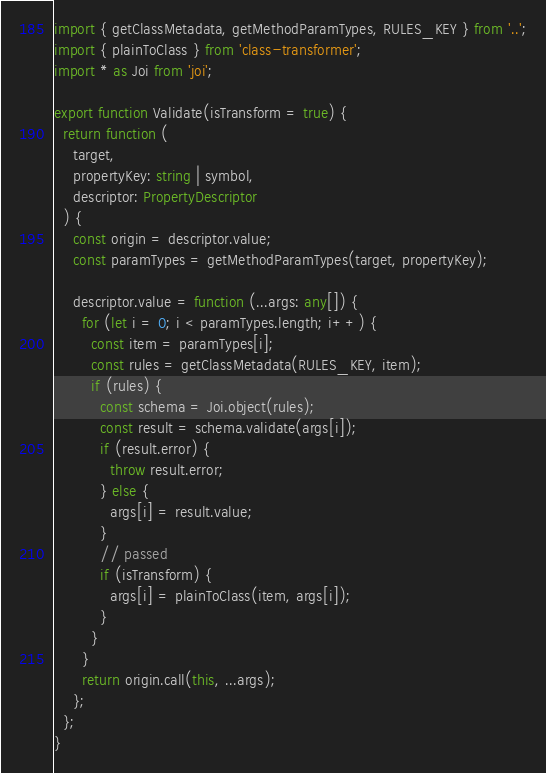Convert code to text. <code><loc_0><loc_0><loc_500><loc_500><_TypeScript_>import { getClassMetadata, getMethodParamTypes, RULES_KEY } from '..';
import { plainToClass } from 'class-transformer';
import * as Joi from 'joi';

export function Validate(isTransform = true) {
  return function (
    target,
    propertyKey: string | symbol,
    descriptor: PropertyDescriptor
  ) {
    const origin = descriptor.value;
    const paramTypes = getMethodParamTypes(target, propertyKey);

    descriptor.value = function (...args: any[]) {
      for (let i = 0; i < paramTypes.length; i++) {
        const item = paramTypes[i];
        const rules = getClassMetadata(RULES_KEY, item);
        if (rules) {
          const schema = Joi.object(rules);
          const result = schema.validate(args[i]);
          if (result.error) {
            throw result.error;
          } else {
            args[i] = result.value;
          }
          // passed
          if (isTransform) {
            args[i] = plainToClass(item, args[i]);
          }
        }
      }
      return origin.call(this, ...args);
    };
  };
}
</code> 